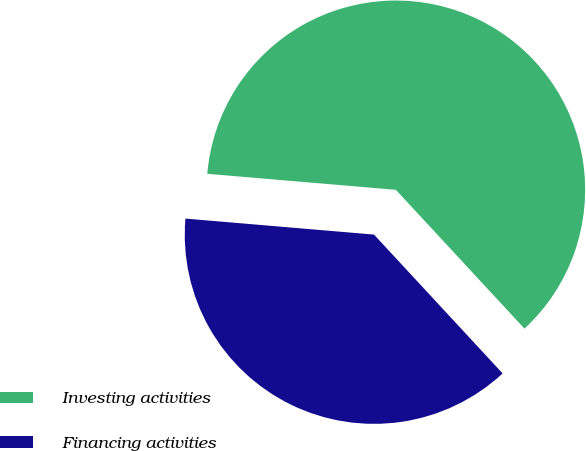<chart> <loc_0><loc_0><loc_500><loc_500><pie_chart><fcel>Investing activities<fcel>Financing activities<nl><fcel>61.76%<fcel>38.24%<nl></chart> 